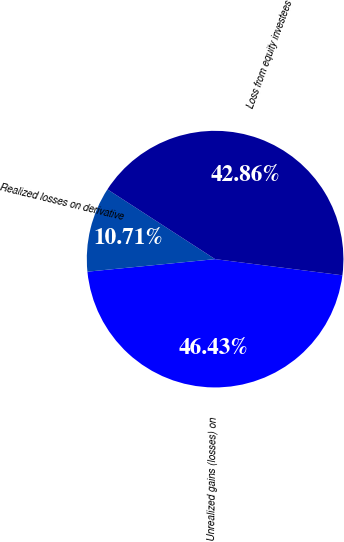<chart> <loc_0><loc_0><loc_500><loc_500><pie_chart><fcel>Unrealized gains (losses) on<fcel>Realized losses on derivative<fcel>Loss from equity investees<nl><fcel>46.43%<fcel>10.71%<fcel>42.86%<nl></chart> 